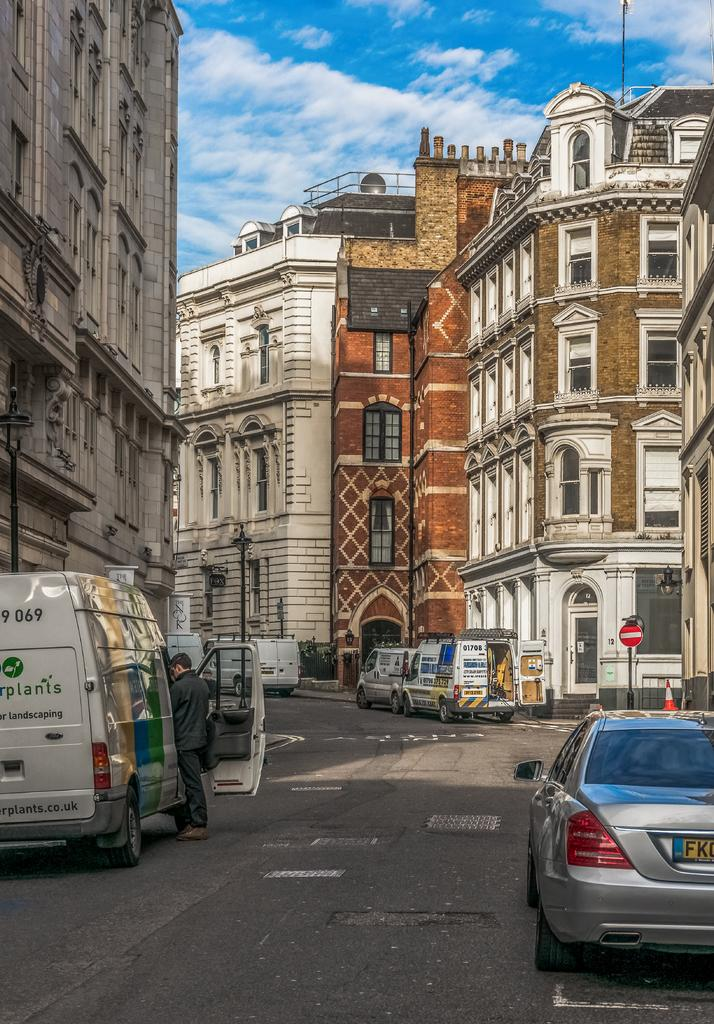What type of structures can be seen in the image? There are buildings in the image. What is on the road in the image? There is a motor vehicle on the road in the image. Can you describe the person in the image? There is a person standing in the image. What are the vertical structures along the road? Street poles are visible in the image. What are the illumination sources in the image? Street lights are present in the image. What type of signs can be seen in the image? Sign boards are in the image. What are the traffic management tools in the image? Traffic cones are in the image. What is visible in the background of the image? The sky is visible in the image. What can be seen in the sky? Clouds are present in the sky. Where is the gate located in the image? There is no gate present in the image. What type of bead is being used to decorate the motor vehicle in the image? There are no beads present in the image, and the motor vehicle is not being decorated. What is the person in the image using to cook their meal? There is no stove present in the image, and the person is not cooking. 